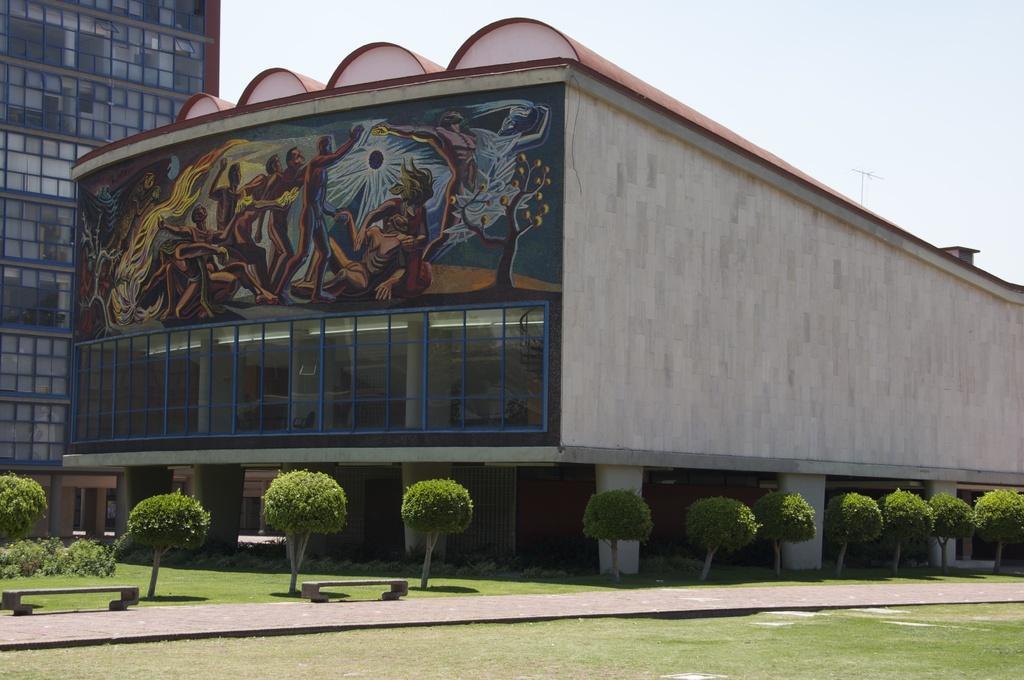Describe this image in one or two sentences. In this image I can see the ground, the path, two benches, few trees which are green in color and few buildings. On the building I can see the painting of few persons. In the background I can see the sky. 